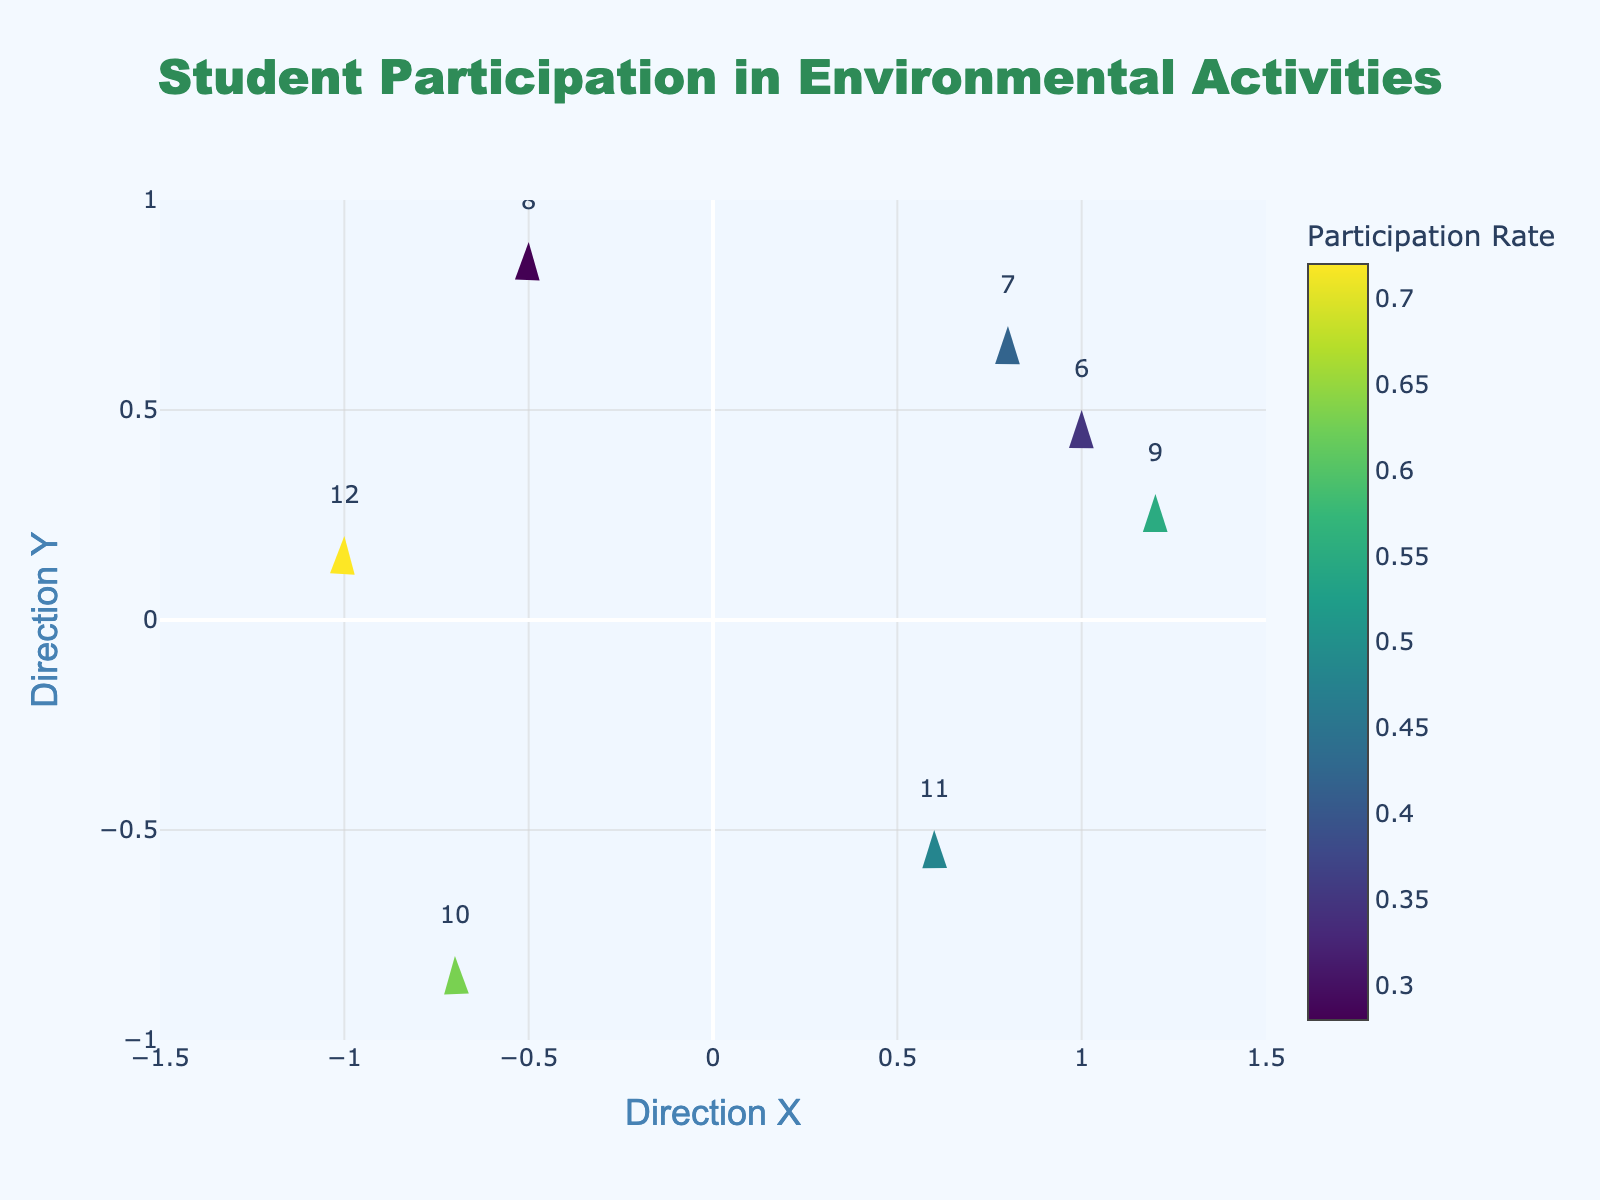What is the title of the figure? The title is usually displayed at the top of the plot. In this case, it can be found by looking at the area designated for the title.
Answer: Student Participation in Environmental Activities What are the X and Y axes labeled as? The X and Y axes labels can be found by looking at the titles on the horizontal and vertical axes of the plot. In this figure, they are explicitly labeled.
Answer: Direction X and Direction Y How many grades are represented in the plot? Each quiver (arrow) in the plot represents one grade, and by counting the number of separate quivers, we can determine the total number of grades.
Answer: 7 Which grade has the highest participation rate? The participation rate is indicated by the color of the markers (arrows). By referring to the color bar and matching the darkest color to its corresponding grade, we can identify the highest rate.
Answer: Grade 12 What direction (X, Y) does the activity with the lowest participation rate point to? The lowest participation rate can be identified using the color bar. Once identified, check the (X, Y) direction associated with that grade's marker.
Answer: (−0.5, 0.9) Which grades have a negative X direction? Grades with a negative X direction can be identified by checking the markers whose X-values are less than zero.
Answer: Grades 8, 10, and 12 What is the participation rate range shown in the plot? To find the range, look at the color bar showing the participation rates. The range would be from the lowest to the highest value shown.
Answer: 0.28 to 0.72 How does Grade 10’s participation direction compare to Grade 11’s? Check the (X, Y) direction values for both grades and compare them to see if they point similarly or differently.
Answer: Grade 10: (−0.7, −0.8), Grade 11: (0.6, −0.5) What is the median participation rate for the grades represented? To find the median, list the participation rates in numerical order and identify the middle value. If there are seven grades, the median is the fourth value in the sorted list.
Answer: 0.48 (7 rates: [0.28, 0.35, 0.42, 0.48, 0.55, 0.63, 0.72], median: 0.48) Which grade has the most vertical direction (highest absolute Y value)? The grade with the highest absolute Y value will be the one with the furthest point above or below zero on the Y-axis.
Answer: Grade 8 (Y = 0.9) 